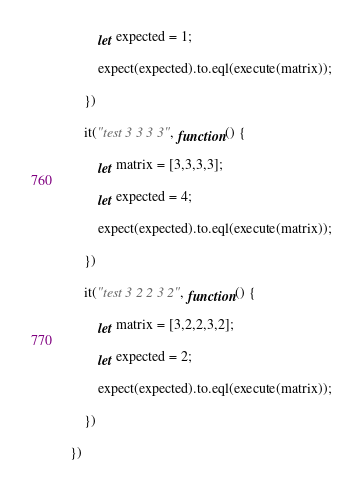<code> <loc_0><loc_0><loc_500><loc_500><_JavaScript_>        let expected = 1;

        expect(expected).to.eql(execute(matrix));
    
    })

    it("test 3 3 3 3", function() {

        let matrix = [3,3,3,3];

        let expected = 4;

        expect(expected).to.eql(execute(matrix));
    
    })

    it("test 3 2 2 3 2", function() {

        let matrix = [3,2,2,3,2];

        let expected = 2;

        expect(expected).to.eql(execute(matrix));
    
    })

})</code> 